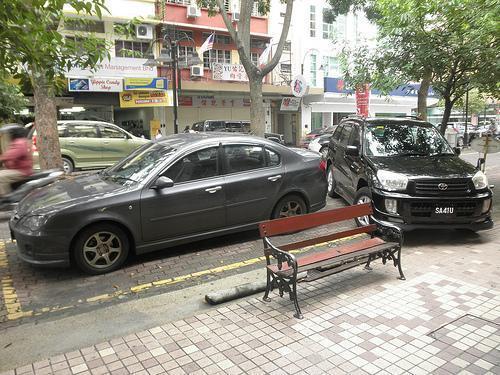How many green cars?
Give a very brief answer. 1. How many benches are there?
Give a very brief answer. 1. 